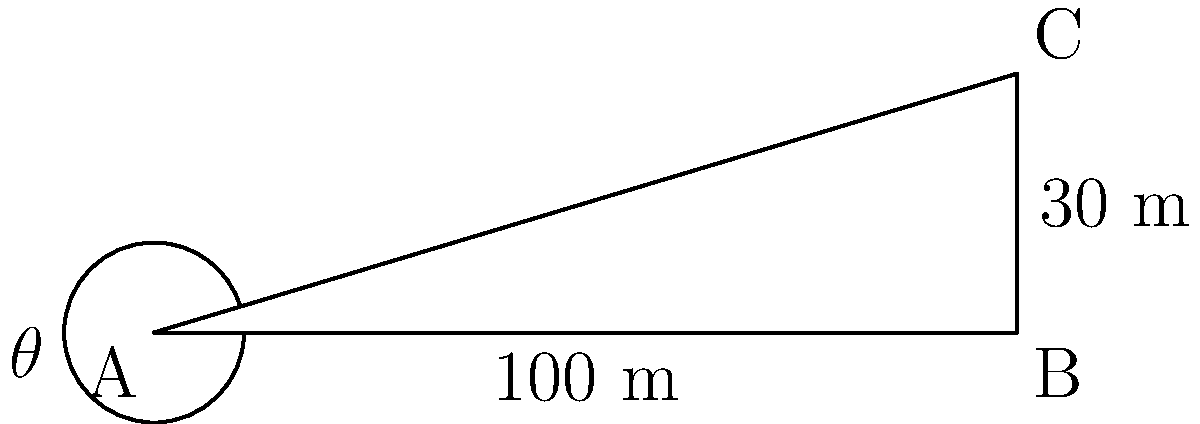A land developer is planning a new residential area and needs to determine the angle of elevation for proper drainage. From point A, the surveyor measures a horizontal distance of 100 meters to point B. At point B, there is a vertical rise of 30 meters to point C. What is the angle of elevation $\theta$ from point A to point C? To solve this problem, we'll use trigonometry, specifically the tangent function. Here's a step-by-step explanation:

1) In the right-angled triangle ABC:
   - The adjacent side (AB) is 100 meters
   - The opposite side (BC) is 30 meters
   - We need to find the angle $\theta$ at A

2) The tangent of an angle in a right-angled triangle is defined as:

   $\tan \theta = \frac{\text{opposite}}{\text{adjacent}}$

3) Substituting our known values:

   $\tan \theta = \frac{30}{100} = 0.3$

4) To find $\theta$, we need to use the inverse tangent (arctan or $\tan^{-1}$):

   $\theta = \tan^{-1}(0.3)$

5) Using a calculator or trigonometric tables:

   $\theta \approx 16.70^\circ$

Therefore, the angle of elevation from point A to point C is approximately 16.70°.
Answer: $16.70^\circ$ 